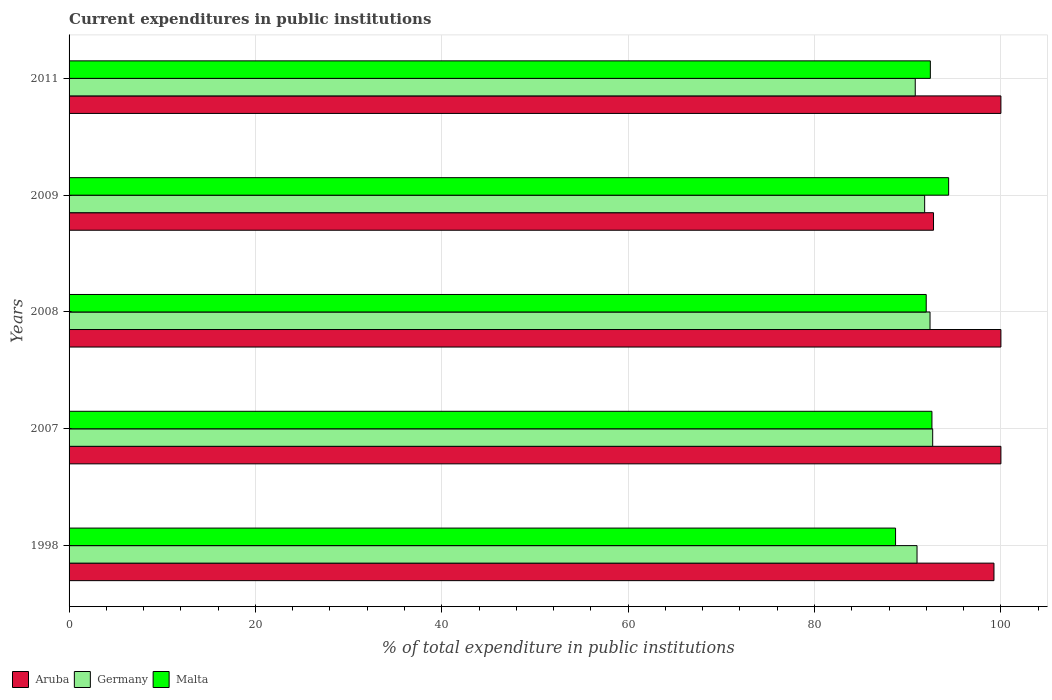How many different coloured bars are there?
Your answer should be very brief. 3. How many groups of bars are there?
Provide a short and direct response. 5. Are the number of bars per tick equal to the number of legend labels?
Offer a very short reply. Yes. How many bars are there on the 3rd tick from the top?
Give a very brief answer. 3. How many bars are there on the 3rd tick from the bottom?
Keep it short and to the point. 3. What is the label of the 1st group of bars from the top?
Make the answer very short. 2011. In how many cases, is the number of bars for a given year not equal to the number of legend labels?
Provide a succinct answer. 0. What is the current expenditures in public institutions in Malta in 2011?
Make the answer very short. 92.43. Across all years, what is the maximum current expenditures in public institutions in Aruba?
Ensure brevity in your answer.  100. Across all years, what is the minimum current expenditures in public institutions in Germany?
Provide a succinct answer. 90.81. In which year was the current expenditures in public institutions in Malta maximum?
Offer a terse response. 2009. In which year was the current expenditures in public institutions in Malta minimum?
Your answer should be very brief. 1998. What is the total current expenditures in public institutions in Malta in the graph?
Give a very brief answer. 460.1. What is the difference between the current expenditures in public institutions in Malta in 2007 and that in 2011?
Your answer should be very brief. 0.17. What is the difference between the current expenditures in public institutions in Aruba in 2009 and the current expenditures in public institutions in Germany in 2008?
Provide a succinct answer. 0.37. What is the average current expenditures in public institutions in Germany per year?
Keep it short and to the point. 91.74. In the year 1998, what is the difference between the current expenditures in public institutions in Germany and current expenditures in public institutions in Aruba?
Your response must be concise. -8.26. What is the ratio of the current expenditures in public institutions in Germany in 2008 to that in 2011?
Your answer should be compact. 1.02. Is the current expenditures in public institutions in Germany in 2009 less than that in 2011?
Offer a terse response. No. Is the difference between the current expenditures in public institutions in Germany in 1998 and 2009 greater than the difference between the current expenditures in public institutions in Aruba in 1998 and 2009?
Offer a very short reply. No. What is the difference between the highest and the lowest current expenditures in public institutions in Aruba?
Provide a short and direct response. 7.23. In how many years, is the current expenditures in public institutions in Germany greater than the average current expenditures in public institutions in Germany taken over all years?
Keep it short and to the point. 3. What does the 3rd bar from the top in 2007 represents?
Offer a very short reply. Aruba. What does the 3rd bar from the bottom in 2007 represents?
Give a very brief answer. Malta. How many bars are there?
Keep it short and to the point. 15. Are all the bars in the graph horizontal?
Provide a short and direct response. Yes. Does the graph contain grids?
Your answer should be very brief. Yes. How many legend labels are there?
Give a very brief answer. 3. How are the legend labels stacked?
Provide a succinct answer. Horizontal. What is the title of the graph?
Offer a terse response. Current expenditures in public institutions. Does "Honduras" appear as one of the legend labels in the graph?
Ensure brevity in your answer.  No. What is the label or title of the X-axis?
Your answer should be very brief. % of total expenditure in public institutions. What is the % of total expenditure in public institutions of Aruba in 1998?
Provide a succinct answer. 99.26. What is the % of total expenditure in public institutions of Germany in 1998?
Provide a succinct answer. 91. What is the % of total expenditure in public institutions of Malta in 1998?
Offer a terse response. 88.7. What is the % of total expenditure in public institutions in Aruba in 2007?
Your answer should be compact. 100. What is the % of total expenditure in public institutions in Germany in 2007?
Provide a short and direct response. 92.68. What is the % of total expenditure in public institutions in Malta in 2007?
Make the answer very short. 92.6. What is the % of total expenditure in public institutions of Germany in 2008?
Your answer should be very brief. 92.39. What is the % of total expenditure in public institutions of Malta in 2008?
Offer a terse response. 91.99. What is the % of total expenditure in public institutions in Aruba in 2009?
Provide a short and direct response. 92.77. What is the % of total expenditure in public institutions of Germany in 2009?
Offer a very short reply. 91.82. What is the % of total expenditure in public institutions of Malta in 2009?
Make the answer very short. 94.39. What is the % of total expenditure in public institutions in Germany in 2011?
Make the answer very short. 90.81. What is the % of total expenditure in public institutions in Malta in 2011?
Your answer should be very brief. 92.43. Across all years, what is the maximum % of total expenditure in public institutions of Aruba?
Give a very brief answer. 100. Across all years, what is the maximum % of total expenditure in public institutions in Germany?
Ensure brevity in your answer.  92.68. Across all years, what is the maximum % of total expenditure in public institutions of Malta?
Ensure brevity in your answer.  94.39. Across all years, what is the minimum % of total expenditure in public institutions of Aruba?
Give a very brief answer. 92.77. Across all years, what is the minimum % of total expenditure in public institutions in Germany?
Give a very brief answer. 90.81. Across all years, what is the minimum % of total expenditure in public institutions in Malta?
Provide a succinct answer. 88.7. What is the total % of total expenditure in public institutions in Aruba in the graph?
Make the answer very short. 492.02. What is the total % of total expenditure in public institutions in Germany in the graph?
Give a very brief answer. 458.7. What is the total % of total expenditure in public institutions in Malta in the graph?
Provide a short and direct response. 460.1. What is the difference between the % of total expenditure in public institutions of Aruba in 1998 and that in 2007?
Your response must be concise. -0.74. What is the difference between the % of total expenditure in public institutions in Germany in 1998 and that in 2007?
Your response must be concise. -1.68. What is the difference between the % of total expenditure in public institutions of Malta in 1998 and that in 2007?
Ensure brevity in your answer.  -3.9. What is the difference between the % of total expenditure in public institutions of Aruba in 1998 and that in 2008?
Keep it short and to the point. -0.74. What is the difference between the % of total expenditure in public institutions in Germany in 1998 and that in 2008?
Provide a short and direct response. -1.4. What is the difference between the % of total expenditure in public institutions of Malta in 1998 and that in 2008?
Ensure brevity in your answer.  -3.29. What is the difference between the % of total expenditure in public institutions of Aruba in 1998 and that in 2009?
Offer a terse response. 6.49. What is the difference between the % of total expenditure in public institutions in Germany in 1998 and that in 2009?
Provide a succinct answer. -0.82. What is the difference between the % of total expenditure in public institutions of Malta in 1998 and that in 2009?
Offer a very short reply. -5.7. What is the difference between the % of total expenditure in public institutions of Aruba in 1998 and that in 2011?
Give a very brief answer. -0.74. What is the difference between the % of total expenditure in public institutions in Germany in 1998 and that in 2011?
Offer a very short reply. 0.19. What is the difference between the % of total expenditure in public institutions in Malta in 1998 and that in 2011?
Offer a terse response. -3.73. What is the difference between the % of total expenditure in public institutions of Germany in 2007 and that in 2008?
Provide a short and direct response. 0.29. What is the difference between the % of total expenditure in public institutions in Malta in 2007 and that in 2008?
Offer a very short reply. 0.61. What is the difference between the % of total expenditure in public institutions of Aruba in 2007 and that in 2009?
Ensure brevity in your answer.  7.23. What is the difference between the % of total expenditure in public institutions of Germany in 2007 and that in 2009?
Your answer should be very brief. 0.86. What is the difference between the % of total expenditure in public institutions of Malta in 2007 and that in 2009?
Provide a succinct answer. -1.79. What is the difference between the % of total expenditure in public institutions in Aruba in 2007 and that in 2011?
Your answer should be very brief. 0. What is the difference between the % of total expenditure in public institutions in Germany in 2007 and that in 2011?
Provide a succinct answer. 1.87. What is the difference between the % of total expenditure in public institutions of Malta in 2007 and that in 2011?
Offer a terse response. 0.17. What is the difference between the % of total expenditure in public institutions of Aruba in 2008 and that in 2009?
Provide a short and direct response. 7.23. What is the difference between the % of total expenditure in public institutions of Germany in 2008 and that in 2009?
Your answer should be compact. 0.58. What is the difference between the % of total expenditure in public institutions of Malta in 2008 and that in 2009?
Your response must be concise. -2.41. What is the difference between the % of total expenditure in public institutions in Germany in 2008 and that in 2011?
Offer a very short reply. 1.59. What is the difference between the % of total expenditure in public institutions in Malta in 2008 and that in 2011?
Ensure brevity in your answer.  -0.44. What is the difference between the % of total expenditure in public institutions of Aruba in 2009 and that in 2011?
Make the answer very short. -7.23. What is the difference between the % of total expenditure in public institutions in Germany in 2009 and that in 2011?
Make the answer very short. 1.01. What is the difference between the % of total expenditure in public institutions in Malta in 2009 and that in 2011?
Give a very brief answer. 1.96. What is the difference between the % of total expenditure in public institutions in Aruba in 1998 and the % of total expenditure in public institutions in Germany in 2007?
Give a very brief answer. 6.58. What is the difference between the % of total expenditure in public institutions of Aruba in 1998 and the % of total expenditure in public institutions of Malta in 2007?
Offer a terse response. 6.66. What is the difference between the % of total expenditure in public institutions of Germany in 1998 and the % of total expenditure in public institutions of Malta in 2007?
Keep it short and to the point. -1.6. What is the difference between the % of total expenditure in public institutions in Aruba in 1998 and the % of total expenditure in public institutions in Germany in 2008?
Provide a succinct answer. 6.86. What is the difference between the % of total expenditure in public institutions in Aruba in 1998 and the % of total expenditure in public institutions in Malta in 2008?
Offer a terse response. 7.27. What is the difference between the % of total expenditure in public institutions of Germany in 1998 and the % of total expenditure in public institutions of Malta in 2008?
Provide a short and direct response. -0.99. What is the difference between the % of total expenditure in public institutions in Aruba in 1998 and the % of total expenditure in public institutions in Germany in 2009?
Provide a short and direct response. 7.44. What is the difference between the % of total expenditure in public institutions of Aruba in 1998 and the % of total expenditure in public institutions of Malta in 2009?
Your response must be concise. 4.86. What is the difference between the % of total expenditure in public institutions in Germany in 1998 and the % of total expenditure in public institutions in Malta in 2009?
Provide a short and direct response. -3.39. What is the difference between the % of total expenditure in public institutions of Aruba in 1998 and the % of total expenditure in public institutions of Germany in 2011?
Your answer should be very brief. 8.45. What is the difference between the % of total expenditure in public institutions of Aruba in 1998 and the % of total expenditure in public institutions of Malta in 2011?
Give a very brief answer. 6.83. What is the difference between the % of total expenditure in public institutions of Germany in 1998 and the % of total expenditure in public institutions of Malta in 2011?
Give a very brief answer. -1.43. What is the difference between the % of total expenditure in public institutions of Aruba in 2007 and the % of total expenditure in public institutions of Germany in 2008?
Make the answer very short. 7.61. What is the difference between the % of total expenditure in public institutions in Aruba in 2007 and the % of total expenditure in public institutions in Malta in 2008?
Make the answer very short. 8.01. What is the difference between the % of total expenditure in public institutions of Germany in 2007 and the % of total expenditure in public institutions of Malta in 2008?
Keep it short and to the point. 0.69. What is the difference between the % of total expenditure in public institutions of Aruba in 2007 and the % of total expenditure in public institutions of Germany in 2009?
Provide a succinct answer. 8.18. What is the difference between the % of total expenditure in public institutions in Aruba in 2007 and the % of total expenditure in public institutions in Malta in 2009?
Ensure brevity in your answer.  5.61. What is the difference between the % of total expenditure in public institutions of Germany in 2007 and the % of total expenditure in public institutions of Malta in 2009?
Give a very brief answer. -1.71. What is the difference between the % of total expenditure in public institutions in Aruba in 2007 and the % of total expenditure in public institutions in Germany in 2011?
Keep it short and to the point. 9.19. What is the difference between the % of total expenditure in public institutions of Aruba in 2007 and the % of total expenditure in public institutions of Malta in 2011?
Your response must be concise. 7.57. What is the difference between the % of total expenditure in public institutions of Germany in 2007 and the % of total expenditure in public institutions of Malta in 2011?
Make the answer very short. 0.25. What is the difference between the % of total expenditure in public institutions of Aruba in 2008 and the % of total expenditure in public institutions of Germany in 2009?
Your answer should be compact. 8.18. What is the difference between the % of total expenditure in public institutions in Aruba in 2008 and the % of total expenditure in public institutions in Malta in 2009?
Give a very brief answer. 5.61. What is the difference between the % of total expenditure in public institutions in Germany in 2008 and the % of total expenditure in public institutions in Malta in 2009?
Offer a very short reply. -2. What is the difference between the % of total expenditure in public institutions in Aruba in 2008 and the % of total expenditure in public institutions in Germany in 2011?
Make the answer very short. 9.19. What is the difference between the % of total expenditure in public institutions in Aruba in 2008 and the % of total expenditure in public institutions in Malta in 2011?
Provide a short and direct response. 7.57. What is the difference between the % of total expenditure in public institutions of Germany in 2008 and the % of total expenditure in public institutions of Malta in 2011?
Give a very brief answer. -0.03. What is the difference between the % of total expenditure in public institutions of Aruba in 2009 and the % of total expenditure in public institutions of Germany in 2011?
Offer a terse response. 1.96. What is the difference between the % of total expenditure in public institutions of Aruba in 2009 and the % of total expenditure in public institutions of Malta in 2011?
Your answer should be very brief. 0.34. What is the difference between the % of total expenditure in public institutions of Germany in 2009 and the % of total expenditure in public institutions of Malta in 2011?
Your answer should be very brief. -0.61. What is the average % of total expenditure in public institutions in Aruba per year?
Make the answer very short. 98.4. What is the average % of total expenditure in public institutions in Germany per year?
Keep it short and to the point. 91.74. What is the average % of total expenditure in public institutions in Malta per year?
Your answer should be compact. 92.02. In the year 1998, what is the difference between the % of total expenditure in public institutions of Aruba and % of total expenditure in public institutions of Germany?
Your answer should be compact. 8.26. In the year 1998, what is the difference between the % of total expenditure in public institutions of Aruba and % of total expenditure in public institutions of Malta?
Ensure brevity in your answer.  10.56. In the year 1998, what is the difference between the % of total expenditure in public institutions in Germany and % of total expenditure in public institutions in Malta?
Provide a succinct answer. 2.3. In the year 2007, what is the difference between the % of total expenditure in public institutions of Aruba and % of total expenditure in public institutions of Germany?
Your answer should be very brief. 7.32. In the year 2007, what is the difference between the % of total expenditure in public institutions of Aruba and % of total expenditure in public institutions of Malta?
Provide a succinct answer. 7.4. In the year 2007, what is the difference between the % of total expenditure in public institutions of Germany and % of total expenditure in public institutions of Malta?
Keep it short and to the point. 0.08. In the year 2008, what is the difference between the % of total expenditure in public institutions of Aruba and % of total expenditure in public institutions of Germany?
Your response must be concise. 7.61. In the year 2008, what is the difference between the % of total expenditure in public institutions in Aruba and % of total expenditure in public institutions in Malta?
Ensure brevity in your answer.  8.01. In the year 2008, what is the difference between the % of total expenditure in public institutions in Germany and % of total expenditure in public institutions in Malta?
Offer a terse response. 0.41. In the year 2009, what is the difference between the % of total expenditure in public institutions in Aruba and % of total expenditure in public institutions in Germany?
Give a very brief answer. 0.95. In the year 2009, what is the difference between the % of total expenditure in public institutions in Aruba and % of total expenditure in public institutions in Malta?
Offer a very short reply. -1.62. In the year 2009, what is the difference between the % of total expenditure in public institutions in Germany and % of total expenditure in public institutions in Malta?
Give a very brief answer. -2.57. In the year 2011, what is the difference between the % of total expenditure in public institutions of Aruba and % of total expenditure in public institutions of Germany?
Provide a succinct answer. 9.19. In the year 2011, what is the difference between the % of total expenditure in public institutions in Aruba and % of total expenditure in public institutions in Malta?
Make the answer very short. 7.57. In the year 2011, what is the difference between the % of total expenditure in public institutions of Germany and % of total expenditure in public institutions of Malta?
Provide a succinct answer. -1.62. What is the ratio of the % of total expenditure in public institutions in Aruba in 1998 to that in 2007?
Your response must be concise. 0.99. What is the ratio of the % of total expenditure in public institutions of Germany in 1998 to that in 2007?
Your answer should be compact. 0.98. What is the ratio of the % of total expenditure in public institutions of Malta in 1998 to that in 2007?
Your answer should be very brief. 0.96. What is the ratio of the % of total expenditure in public institutions of Aruba in 1998 to that in 2008?
Your answer should be compact. 0.99. What is the ratio of the % of total expenditure in public institutions of Germany in 1998 to that in 2008?
Your response must be concise. 0.98. What is the ratio of the % of total expenditure in public institutions in Malta in 1998 to that in 2008?
Your answer should be compact. 0.96. What is the ratio of the % of total expenditure in public institutions of Aruba in 1998 to that in 2009?
Offer a terse response. 1.07. What is the ratio of the % of total expenditure in public institutions of Malta in 1998 to that in 2009?
Offer a very short reply. 0.94. What is the ratio of the % of total expenditure in public institutions in Aruba in 1998 to that in 2011?
Provide a succinct answer. 0.99. What is the ratio of the % of total expenditure in public institutions of Malta in 1998 to that in 2011?
Give a very brief answer. 0.96. What is the ratio of the % of total expenditure in public institutions in Aruba in 2007 to that in 2008?
Your answer should be very brief. 1. What is the ratio of the % of total expenditure in public institutions of Aruba in 2007 to that in 2009?
Make the answer very short. 1.08. What is the ratio of the % of total expenditure in public institutions in Germany in 2007 to that in 2009?
Provide a succinct answer. 1.01. What is the ratio of the % of total expenditure in public institutions in Aruba in 2007 to that in 2011?
Your response must be concise. 1. What is the ratio of the % of total expenditure in public institutions in Germany in 2007 to that in 2011?
Offer a very short reply. 1.02. What is the ratio of the % of total expenditure in public institutions in Malta in 2007 to that in 2011?
Your answer should be very brief. 1. What is the ratio of the % of total expenditure in public institutions in Aruba in 2008 to that in 2009?
Your response must be concise. 1.08. What is the ratio of the % of total expenditure in public institutions of Malta in 2008 to that in 2009?
Your answer should be very brief. 0.97. What is the ratio of the % of total expenditure in public institutions of Aruba in 2008 to that in 2011?
Give a very brief answer. 1. What is the ratio of the % of total expenditure in public institutions in Germany in 2008 to that in 2011?
Your response must be concise. 1.02. What is the ratio of the % of total expenditure in public institutions of Malta in 2008 to that in 2011?
Keep it short and to the point. 1. What is the ratio of the % of total expenditure in public institutions in Aruba in 2009 to that in 2011?
Offer a terse response. 0.93. What is the ratio of the % of total expenditure in public institutions in Germany in 2009 to that in 2011?
Make the answer very short. 1.01. What is the ratio of the % of total expenditure in public institutions in Malta in 2009 to that in 2011?
Give a very brief answer. 1.02. What is the difference between the highest and the second highest % of total expenditure in public institutions in Germany?
Offer a terse response. 0.29. What is the difference between the highest and the second highest % of total expenditure in public institutions of Malta?
Keep it short and to the point. 1.79. What is the difference between the highest and the lowest % of total expenditure in public institutions of Aruba?
Make the answer very short. 7.23. What is the difference between the highest and the lowest % of total expenditure in public institutions of Germany?
Your answer should be very brief. 1.87. What is the difference between the highest and the lowest % of total expenditure in public institutions of Malta?
Give a very brief answer. 5.7. 